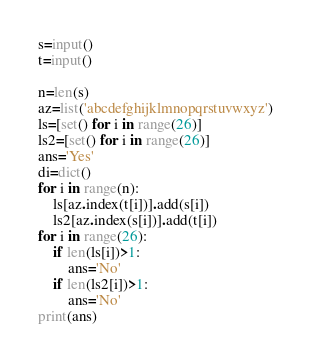<code> <loc_0><loc_0><loc_500><loc_500><_Python_>s=input()
t=input()

n=len(s)
az=list('abcdefghijklmnopqrstuvwxyz')
ls=[set() for i in range(26)]
ls2=[set() for i in range(26)]
ans='Yes'
di=dict()
for i in range(n):
    ls[az.index(t[i])].add(s[i])
    ls2[az.index(s[i])].add(t[i])
for i in range(26):
    if len(ls[i])>1:
        ans='No'
    if len(ls2[i])>1:
        ans='No'
print(ans)

</code> 